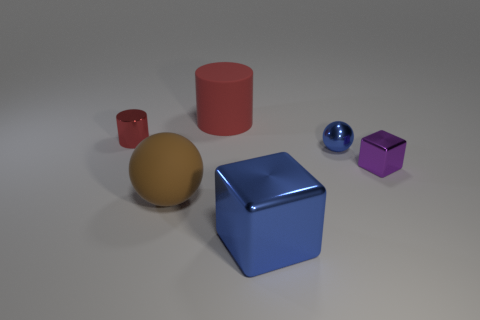The tiny object that is both in front of the shiny cylinder and on the left side of the tiny purple thing is what color?
Make the answer very short. Blue. How many matte cylinders have the same color as the small metallic ball?
Your answer should be compact. 0. What number of balls are brown things or large red objects?
Make the answer very short. 1. There is a ball that is the same size as the purple metallic block; what color is it?
Keep it short and to the point. Blue. There is a tiny thing behind the ball that is on the right side of the large brown rubber thing; is there a blue ball that is on the right side of it?
Make the answer very short. Yes. The matte cylinder has what size?
Keep it short and to the point. Large. What number of objects are either large red cylinders or big things?
Ensure brevity in your answer.  3. There is a large cylinder that is made of the same material as the big brown sphere; what color is it?
Offer a very short reply. Red. There is a object that is on the right side of the blue ball; is its shape the same as the small blue shiny thing?
Keep it short and to the point. No. How many things are big objects that are in front of the small purple cube or large things in front of the blue metal sphere?
Make the answer very short. 2. 